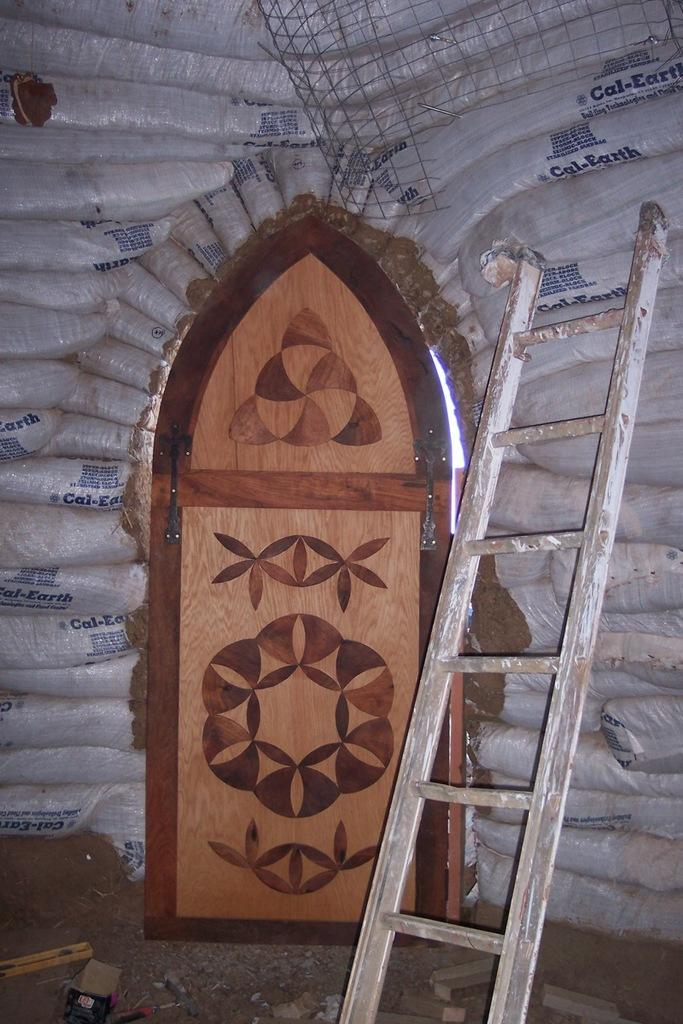What type of objects can be seen in the image? There are bags in the image. What is the purpose of the ladder in the image? The ladder is likely used for reaching higher areas. What type of barrier is present in the image? There is a fence in the image. What is the purpose of the door in the image? The door is likely used for entering or exiting a building or room. What can be found on the ground in the image? There are objects on the ground in the image. What type of nose can be seen on the fence in the image? There is no nose present on the fence in the image. 